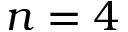<formula> <loc_0><loc_0><loc_500><loc_500>n = 4</formula> 